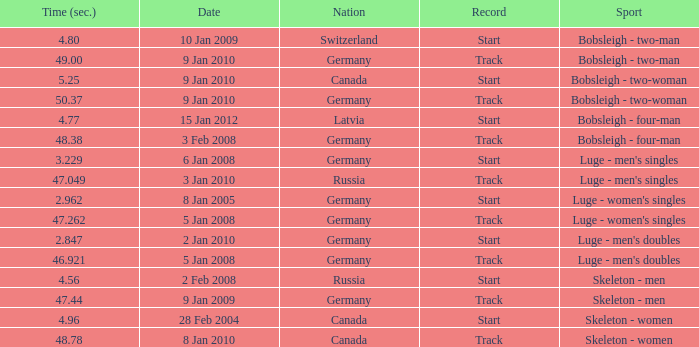Parse the full table. {'header': ['Time (sec.)', 'Date', 'Nation', 'Record', 'Sport'], 'rows': [['4.80', '10 Jan 2009', 'Switzerland', 'Start', 'Bobsleigh - two-man'], ['49.00', '9 Jan 2010', 'Germany', 'Track', 'Bobsleigh - two-man'], ['5.25', '9 Jan 2010', 'Canada', 'Start', 'Bobsleigh - two-woman'], ['50.37', '9 Jan 2010', 'Germany', 'Track', 'Bobsleigh - two-woman'], ['4.77', '15 Jan 2012', 'Latvia', 'Start', 'Bobsleigh - four-man'], ['48.38', '3 Feb 2008', 'Germany', 'Track', 'Bobsleigh - four-man'], ['3.229', '6 Jan 2008', 'Germany', 'Start', "Luge - men's singles"], ['47.049', '3 Jan 2010', 'Russia', 'Track', "Luge - men's singles"], ['2.962', '8 Jan 2005', 'Germany', 'Start', "Luge - women's singles"], ['47.262', '5 Jan 2008', 'Germany', 'Track', "Luge - women's singles"], ['2.847', '2 Jan 2010', 'Germany', 'Start', "Luge - men's doubles"], ['46.921', '5 Jan 2008', 'Germany', 'Track', "Luge - men's doubles"], ['4.56', '2 Feb 2008', 'Russia', 'Start', 'Skeleton - men'], ['47.44', '9 Jan 2009', 'Germany', 'Track', 'Skeleton - men'], ['4.96', '28 Feb 2004', 'Canada', 'Start', 'Skeleton - women'], ['48.78', '8 Jan 2010', 'Canada', 'Track', 'Skeleton - women']]} 049? Russia. 